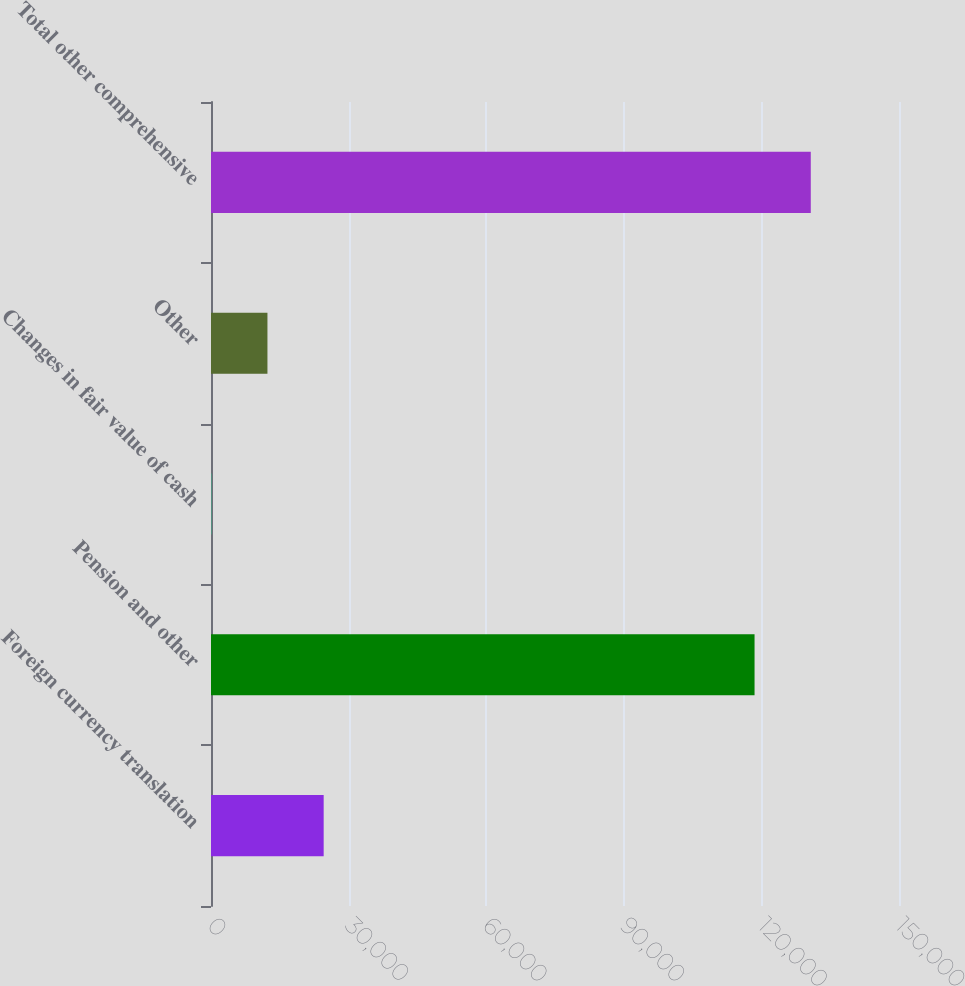<chart> <loc_0><loc_0><loc_500><loc_500><bar_chart><fcel>Foreign currency translation<fcel>Pension and other<fcel>Changes in fair value of cash<fcel>Other<fcel>Total other comprehensive<nl><fcel>24565<fcel>118507<fcel>49<fcel>12307<fcel>130765<nl></chart> 